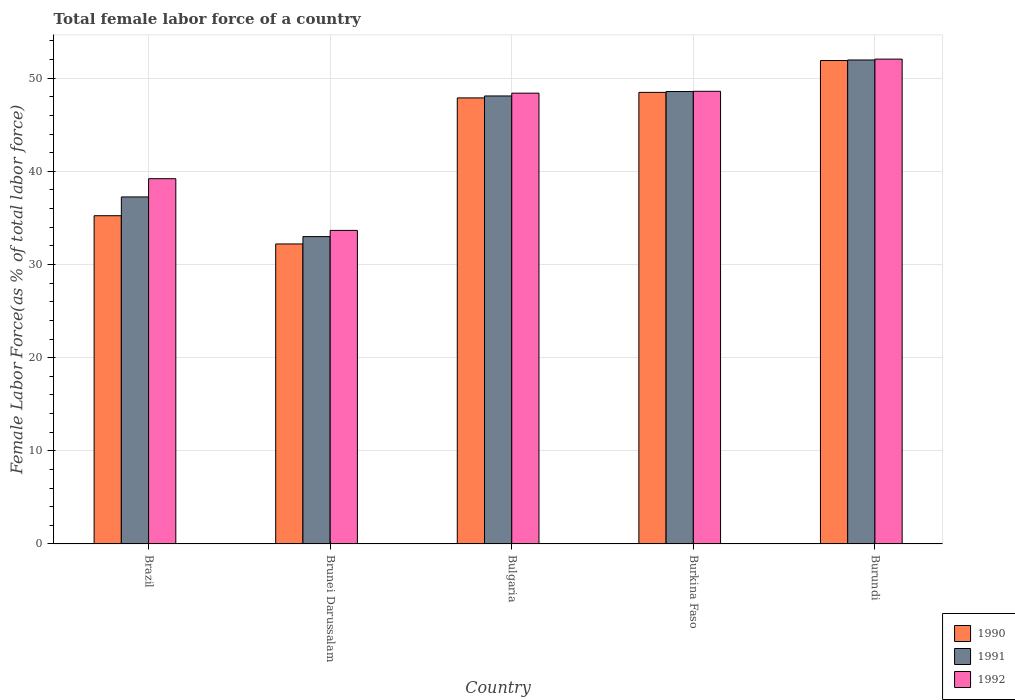How many different coloured bars are there?
Provide a short and direct response. 3. How many groups of bars are there?
Give a very brief answer. 5. What is the label of the 1st group of bars from the left?
Give a very brief answer. Brazil. In how many cases, is the number of bars for a given country not equal to the number of legend labels?
Your response must be concise. 0. What is the percentage of female labor force in 1990 in Brunei Darussalam?
Provide a short and direct response. 32.2. Across all countries, what is the maximum percentage of female labor force in 1990?
Provide a succinct answer. 51.89. Across all countries, what is the minimum percentage of female labor force in 1990?
Your answer should be very brief. 32.2. In which country was the percentage of female labor force in 1991 maximum?
Your answer should be very brief. Burundi. In which country was the percentage of female labor force in 1991 minimum?
Offer a terse response. Brunei Darussalam. What is the total percentage of female labor force in 1992 in the graph?
Provide a short and direct response. 221.91. What is the difference between the percentage of female labor force in 1990 in Brunei Darussalam and that in Bulgaria?
Your answer should be very brief. -15.68. What is the difference between the percentage of female labor force in 1992 in Brunei Darussalam and the percentage of female labor force in 1990 in Burkina Faso?
Give a very brief answer. -14.82. What is the average percentage of female labor force in 1991 per country?
Make the answer very short. 43.77. What is the difference between the percentage of female labor force of/in 1992 and percentage of female labor force of/in 1990 in Bulgaria?
Offer a very short reply. 0.51. What is the ratio of the percentage of female labor force in 1991 in Brunei Darussalam to that in Bulgaria?
Ensure brevity in your answer.  0.69. Is the percentage of female labor force in 1992 in Brunei Darussalam less than that in Burkina Faso?
Offer a very short reply. Yes. Is the difference between the percentage of female labor force in 1992 in Brazil and Bulgaria greater than the difference between the percentage of female labor force in 1990 in Brazil and Bulgaria?
Your response must be concise. Yes. What is the difference between the highest and the second highest percentage of female labor force in 1991?
Your response must be concise. 0.48. What is the difference between the highest and the lowest percentage of female labor force in 1990?
Give a very brief answer. 19.69. In how many countries, is the percentage of female labor force in 1991 greater than the average percentage of female labor force in 1991 taken over all countries?
Your answer should be compact. 3. What does the 3rd bar from the right in Brazil represents?
Offer a terse response. 1990. Is it the case that in every country, the sum of the percentage of female labor force in 1990 and percentage of female labor force in 1992 is greater than the percentage of female labor force in 1991?
Offer a terse response. Yes. How many bars are there?
Provide a short and direct response. 15. Are all the bars in the graph horizontal?
Ensure brevity in your answer.  No. Does the graph contain grids?
Ensure brevity in your answer.  Yes. Where does the legend appear in the graph?
Offer a very short reply. Bottom right. How are the legend labels stacked?
Offer a very short reply. Vertical. What is the title of the graph?
Your response must be concise. Total female labor force of a country. Does "1980" appear as one of the legend labels in the graph?
Make the answer very short. No. What is the label or title of the X-axis?
Keep it short and to the point. Country. What is the label or title of the Y-axis?
Keep it short and to the point. Female Labor Force(as % of total labor force). What is the Female Labor Force(as % of total labor force) in 1990 in Brazil?
Keep it short and to the point. 35.24. What is the Female Labor Force(as % of total labor force) in 1991 in Brazil?
Ensure brevity in your answer.  37.25. What is the Female Labor Force(as % of total labor force) of 1992 in Brazil?
Your response must be concise. 39.21. What is the Female Labor Force(as % of total labor force) in 1990 in Brunei Darussalam?
Your answer should be very brief. 32.2. What is the Female Labor Force(as % of total labor force) in 1991 in Brunei Darussalam?
Your response must be concise. 33. What is the Female Labor Force(as % of total labor force) in 1992 in Brunei Darussalam?
Your answer should be very brief. 33.66. What is the Female Labor Force(as % of total labor force) of 1990 in Bulgaria?
Give a very brief answer. 47.88. What is the Female Labor Force(as % of total labor force) of 1991 in Bulgaria?
Your response must be concise. 48.09. What is the Female Labor Force(as % of total labor force) of 1992 in Bulgaria?
Give a very brief answer. 48.39. What is the Female Labor Force(as % of total labor force) in 1990 in Burkina Faso?
Your answer should be very brief. 48.48. What is the Female Labor Force(as % of total labor force) of 1991 in Burkina Faso?
Make the answer very short. 48.57. What is the Female Labor Force(as % of total labor force) of 1992 in Burkina Faso?
Offer a very short reply. 48.59. What is the Female Labor Force(as % of total labor force) in 1990 in Burundi?
Offer a very short reply. 51.89. What is the Female Labor Force(as % of total labor force) of 1991 in Burundi?
Your response must be concise. 51.96. What is the Female Labor Force(as % of total labor force) of 1992 in Burundi?
Provide a short and direct response. 52.05. Across all countries, what is the maximum Female Labor Force(as % of total labor force) of 1990?
Give a very brief answer. 51.89. Across all countries, what is the maximum Female Labor Force(as % of total labor force) of 1991?
Make the answer very short. 51.96. Across all countries, what is the maximum Female Labor Force(as % of total labor force) of 1992?
Provide a succinct answer. 52.05. Across all countries, what is the minimum Female Labor Force(as % of total labor force) of 1990?
Your response must be concise. 32.2. Across all countries, what is the minimum Female Labor Force(as % of total labor force) in 1991?
Your answer should be compact. 33. Across all countries, what is the minimum Female Labor Force(as % of total labor force) in 1992?
Your answer should be compact. 33.66. What is the total Female Labor Force(as % of total labor force) of 1990 in the graph?
Provide a short and direct response. 215.7. What is the total Female Labor Force(as % of total labor force) of 1991 in the graph?
Offer a terse response. 218.86. What is the total Female Labor Force(as % of total labor force) in 1992 in the graph?
Give a very brief answer. 221.91. What is the difference between the Female Labor Force(as % of total labor force) in 1990 in Brazil and that in Brunei Darussalam?
Keep it short and to the point. 3.03. What is the difference between the Female Labor Force(as % of total labor force) of 1991 in Brazil and that in Brunei Darussalam?
Your response must be concise. 4.26. What is the difference between the Female Labor Force(as % of total labor force) in 1992 in Brazil and that in Brunei Darussalam?
Offer a very short reply. 5.55. What is the difference between the Female Labor Force(as % of total labor force) of 1990 in Brazil and that in Bulgaria?
Keep it short and to the point. -12.65. What is the difference between the Female Labor Force(as % of total labor force) of 1991 in Brazil and that in Bulgaria?
Provide a succinct answer. -10.84. What is the difference between the Female Labor Force(as % of total labor force) of 1992 in Brazil and that in Bulgaria?
Give a very brief answer. -9.18. What is the difference between the Female Labor Force(as % of total labor force) of 1990 in Brazil and that in Burkina Faso?
Your answer should be very brief. -13.24. What is the difference between the Female Labor Force(as % of total labor force) in 1991 in Brazil and that in Burkina Faso?
Your answer should be very brief. -11.31. What is the difference between the Female Labor Force(as % of total labor force) in 1992 in Brazil and that in Burkina Faso?
Your response must be concise. -9.38. What is the difference between the Female Labor Force(as % of total labor force) in 1990 in Brazil and that in Burundi?
Your answer should be compact. -16.66. What is the difference between the Female Labor Force(as % of total labor force) in 1991 in Brazil and that in Burundi?
Your response must be concise. -14.7. What is the difference between the Female Labor Force(as % of total labor force) of 1992 in Brazil and that in Burundi?
Make the answer very short. -12.84. What is the difference between the Female Labor Force(as % of total labor force) in 1990 in Brunei Darussalam and that in Bulgaria?
Offer a terse response. -15.68. What is the difference between the Female Labor Force(as % of total labor force) in 1991 in Brunei Darussalam and that in Bulgaria?
Offer a terse response. -15.1. What is the difference between the Female Labor Force(as % of total labor force) in 1992 in Brunei Darussalam and that in Bulgaria?
Your answer should be compact. -14.73. What is the difference between the Female Labor Force(as % of total labor force) of 1990 in Brunei Darussalam and that in Burkina Faso?
Provide a short and direct response. -16.27. What is the difference between the Female Labor Force(as % of total labor force) in 1991 in Brunei Darussalam and that in Burkina Faso?
Provide a succinct answer. -15.57. What is the difference between the Female Labor Force(as % of total labor force) in 1992 in Brunei Darussalam and that in Burkina Faso?
Ensure brevity in your answer.  -14.93. What is the difference between the Female Labor Force(as % of total labor force) of 1990 in Brunei Darussalam and that in Burundi?
Provide a short and direct response. -19.69. What is the difference between the Female Labor Force(as % of total labor force) of 1991 in Brunei Darussalam and that in Burundi?
Provide a succinct answer. -18.96. What is the difference between the Female Labor Force(as % of total labor force) in 1992 in Brunei Darussalam and that in Burundi?
Offer a terse response. -18.39. What is the difference between the Female Labor Force(as % of total labor force) in 1990 in Bulgaria and that in Burkina Faso?
Give a very brief answer. -0.59. What is the difference between the Female Labor Force(as % of total labor force) in 1991 in Bulgaria and that in Burkina Faso?
Provide a succinct answer. -0.48. What is the difference between the Female Labor Force(as % of total labor force) in 1992 in Bulgaria and that in Burkina Faso?
Your answer should be compact. -0.2. What is the difference between the Female Labor Force(as % of total labor force) of 1990 in Bulgaria and that in Burundi?
Keep it short and to the point. -4.01. What is the difference between the Female Labor Force(as % of total labor force) of 1991 in Bulgaria and that in Burundi?
Make the answer very short. -3.86. What is the difference between the Female Labor Force(as % of total labor force) in 1992 in Bulgaria and that in Burundi?
Provide a succinct answer. -3.65. What is the difference between the Female Labor Force(as % of total labor force) of 1990 in Burkina Faso and that in Burundi?
Provide a succinct answer. -3.42. What is the difference between the Female Labor Force(as % of total labor force) in 1991 in Burkina Faso and that in Burundi?
Make the answer very short. -3.39. What is the difference between the Female Labor Force(as % of total labor force) in 1992 in Burkina Faso and that in Burundi?
Keep it short and to the point. -3.45. What is the difference between the Female Labor Force(as % of total labor force) in 1990 in Brazil and the Female Labor Force(as % of total labor force) in 1991 in Brunei Darussalam?
Make the answer very short. 2.24. What is the difference between the Female Labor Force(as % of total labor force) in 1990 in Brazil and the Female Labor Force(as % of total labor force) in 1992 in Brunei Darussalam?
Your answer should be very brief. 1.58. What is the difference between the Female Labor Force(as % of total labor force) of 1991 in Brazil and the Female Labor Force(as % of total labor force) of 1992 in Brunei Darussalam?
Your response must be concise. 3.59. What is the difference between the Female Labor Force(as % of total labor force) of 1990 in Brazil and the Female Labor Force(as % of total labor force) of 1991 in Bulgaria?
Provide a short and direct response. -12.86. What is the difference between the Female Labor Force(as % of total labor force) in 1990 in Brazil and the Female Labor Force(as % of total labor force) in 1992 in Bulgaria?
Provide a short and direct response. -13.16. What is the difference between the Female Labor Force(as % of total labor force) in 1991 in Brazil and the Female Labor Force(as % of total labor force) in 1992 in Bulgaria?
Provide a succinct answer. -11.14. What is the difference between the Female Labor Force(as % of total labor force) of 1990 in Brazil and the Female Labor Force(as % of total labor force) of 1991 in Burkina Faso?
Make the answer very short. -13.33. What is the difference between the Female Labor Force(as % of total labor force) of 1990 in Brazil and the Female Labor Force(as % of total labor force) of 1992 in Burkina Faso?
Provide a succinct answer. -13.36. What is the difference between the Female Labor Force(as % of total labor force) in 1991 in Brazil and the Female Labor Force(as % of total labor force) in 1992 in Burkina Faso?
Provide a succinct answer. -11.34. What is the difference between the Female Labor Force(as % of total labor force) in 1990 in Brazil and the Female Labor Force(as % of total labor force) in 1991 in Burundi?
Your answer should be compact. -16.72. What is the difference between the Female Labor Force(as % of total labor force) in 1990 in Brazil and the Female Labor Force(as % of total labor force) in 1992 in Burundi?
Give a very brief answer. -16.81. What is the difference between the Female Labor Force(as % of total labor force) of 1991 in Brazil and the Female Labor Force(as % of total labor force) of 1992 in Burundi?
Offer a terse response. -14.79. What is the difference between the Female Labor Force(as % of total labor force) in 1990 in Brunei Darussalam and the Female Labor Force(as % of total labor force) in 1991 in Bulgaria?
Your answer should be very brief. -15.89. What is the difference between the Female Labor Force(as % of total labor force) in 1990 in Brunei Darussalam and the Female Labor Force(as % of total labor force) in 1992 in Bulgaria?
Keep it short and to the point. -16.19. What is the difference between the Female Labor Force(as % of total labor force) of 1991 in Brunei Darussalam and the Female Labor Force(as % of total labor force) of 1992 in Bulgaria?
Provide a succinct answer. -15.4. What is the difference between the Female Labor Force(as % of total labor force) in 1990 in Brunei Darussalam and the Female Labor Force(as % of total labor force) in 1991 in Burkina Faso?
Provide a succinct answer. -16.36. What is the difference between the Female Labor Force(as % of total labor force) in 1990 in Brunei Darussalam and the Female Labor Force(as % of total labor force) in 1992 in Burkina Faso?
Your answer should be very brief. -16.39. What is the difference between the Female Labor Force(as % of total labor force) of 1991 in Brunei Darussalam and the Female Labor Force(as % of total labor force) of 1992 in Burkina Faso?
Ensure brevity in your answer.  -15.6. What is the difference between the Female Labor Force(as % of total labor force) of 1990 in Brunei Darussalam and the Female Labor Force(as % of total labor force) of 1991 in Burundi?
Offer a terse response. -19.75. What is the difference between the Female Labor Force(as % of total labor force) of 1990 in Brunei Darussalam and the Female Labor Force(as % of total labor force) of 1992 in Burundi?
Your answer should be compact. -19.84. What is the difference between the Female Labor Force(as % of total labor force) of 1991 in Brunei Darussalam and the Female Labor Force(as % of total labor force) of 1992 in Burundi?
Your answer should be very brief. -19.05. What is the difference between the Female Labor Force(as % of total labor force) of 1990 in Bulgaria and the Female Labor Force(as % of total labor force) of 1991 in Burkina Faso?
Provide a short and direct response. -0.68. What is the difference between the Female Labor Force(as % of total labor force) of 1990 in Bulgaria and the Female Labor Force(as % of total labor force) of 1992 in Burkina Faso?
Your response must be concise. -0.71. What is the difference between the Female Labor Force(as % of total labor force) in 1991 in Bulgaria and the Female Labor Force(as % of total labor force) in 1992 in Burkina Faso?
Keep it short and to the point. -0.5. What is the difference between the Female Labor Force(as % of total labor force) of 1990 in Bulgaria and the Female Labor Force(as % of total labor force) of 1991 in Burundi?
Your answer should be compact. -4.07. What is the difference between the Female Labor Force(as % of total labor force) of 1990 in Bulgaria and the Female Labor Force(as % of total labor force) of 1992 in Burundi?
Keep it short and to the point. -4.16. What is the difference between the Female Labor Force(as % of total labor force) of 1991 in Bulgaria and the Female Labor Force(as % of total labor force) of 1992 in Burundi?
Offer a terse response. -3.95. What is the difference between the Female Labor Force(as % of total labor force) of 1990 in Burkina Faso and the Female Labor Force(as % of total labor force) of 1991 in Burundi?
Your answer should be compact. -3.48. What is the difference between the Female Labor Force(as % of total labor force) of 1990 in Burkina Faso and the Female Labor Force(as % of total labor force) of 1992 in Burundi?
Keep it short and to the point. -3.57. What is the difference between the Female Labor Force(as % of total labor force) in 1991 in Burkina Faso and the Female Labor Force(as % of total labor force) in 1992 in Burundi?
Provide a short and direct response. -3.48. What is the average Female Labor Force(as % of total labor force) in 1990 per country?
Keep it short and to the point. 43.14. What is the average Female Labor Force(as % of total labor force) of 1991 per country?
Provide a succinct answer. 43.77. What is the average Female Labor Force(as % of total labor force) in 1992 per country?
Your answer should be compact. 44.38. What is the difference between the Female Labor Force(as % of total labor force) in 1990 and Female Labor Force(as % of total labor force) in 1991 in Brazil?
Your response must be concise. -2.02. What is the difference between the Female Labor Force(as % of total labor force) in 1990 and Female Labor Force(as % of total labor force) in 1992 in Brazil?
Your response must be concise. -3.97. What is the difference between the Female Labor Force(as % of total labor force) of 1991 and Female Labor Force(as % of total labor force) of 1992 in Brazil?
Ensure brevity in your answer.  -1.96. What is the difference between the Female Labor Force(as % of total labor force) in 1990 and Female Labor Force(as % of total labor force) in 1991 in Brunei Darussalam?
Offer a terse response. -0.79. What is the difference between the Female Labor Force(as % of total labor force) of 1990 and Female Labor Force(as % of total labor force) of 1992 in Brunei Darussalam?
Provide a short and direct response. -1.46. What is the difference between the Female Labor Force(as % of total labor force) in 1991 and Female Labor Force(as % of total labor force) in 1992 in Brunei Darussalam?
Provide a succinct answer. -0.66. What is the difference between the Female Labor Force(as % of total labor force) of 1990 and Female Labor Force(as % of total labor force) of 1991 in Bulgaria?
Your answer should be compact. -0.21. What is the difference between the Female Labor Force(as % of total labor force) in 1990 and Female Labor Force(as % of total labor force) in 1992 in Bulgaria?
Keep it short and to the point. -0.51. What is the difference between the Female Labor Force(as % of total labor force) in 1991 and Female Labor Force(as % of total labor force) in 1992 in Bulgaria?
Make the answer very short. -0.3. What is the difference between the Female Labor Force(as % of total labor force) in 1990 and Female Labor Force(as % of total labor force) in 1991 in Burkina Faso?
Provide a succinct answer. -0.09. What is the difference between the Female Labor Force(as % of total labor force) in 1990 and Female Labor Force(as % of total labor force) in 1992 in Burkina Faso?
Offer a very short reply. -0.12. What is the difference between the Female Labor Force(as % of total labor force) of 1991 and Female Labor Force(as % of total labor force) of 1992 in Burkina Faso?
Provide a succinct answer. -0.03. What is the difference between the Female Labor Force(as % of total labor force) of 1990 and Female Labor Force(as % of total labor force) of 1991 in Burundi?
Your answer should be compact. -0.06. What is the difference between the Female Labor Force(as % of total labor force) of 1990 and Female Labor Force(as % of total labor force) of 1992 in Burundi?
Your answer should be compact. -0.15. What is the difference between the Female Labor Force(as % of total labor force) in 1991 and Female Labor Force(as % of total labor force) in 1992 in Burundi?
Give a very brief answer. -0.09. What is the ratio of the Female Labor Force(as % of total labor force) in 1990 in Brazil to that in Brunei Darussalam?
Keep it short and to the point. 1.09. What is the ratio of the Female Labor Force(as % of total labor force) in 1991 in Brazil to that in Brunei Darussalam?
Make the answer very short. 1.13. What is the ratio of the Female Labor Force(as % of total labor force) of 1992 in Brazil to that in Brunei Darussalam?
Offer a very short reply. 1.16. What is the ratio of the Female Labor Force(as % of total labor force) in 1990 in Brazil to that in Bulgaria?
Your response must be concise. 0.74. What is the ratio of the Female Labor Force(as % of total labor force) of 1991 in Brazil to that in Bulgaria?
Your response must be concise. 0.77. What is the ratio of the Female Labor Force(as % of total labor force) of 1992 in Brazil to that in Bulgaria?
Offer a terse response. 0.81. What is the ratio of the Female Labor Force(as % of total labor force) in 1990 in Brazil to that in Burkina Faso?
Keep it short and to the point. 0.73. What is the ratio of the Female Labor Force(as % of total labor force) of 1991 in Brazil to that in Burkina Faso?
Your answer should be very brief. 0.77. What is the ratio of the Female Labor Force(as % of total labor force) of 1992 in Brazil to that in Burkina Faso?
Provide a short and direct response. 0.81. What is the ratio of the Female Labor Force(as % of total labor force) in 1990 in Brazil to that in Burundi?
Your response must be concise. 0.68. What is the ratio of the Female Labor Force(as % of total labor force) of 1991 in Brazil to that in Burundi?
Keep it short and to the point. 0.72. What is the ratio of the Female Labor Force(as % of total labor force) of 1992 in Brazil to that in Burundi?
Offer a very short reply. 0.75. What is the ratio of the Female Labor Force(as % of total labor force) in 1990 in Brunei Darussalam to that in Bulgaria?
Offer a very short reply. 0.67. What is the ratio of the Female Labor Force(as % of total labor force) of 1991 in Brunei Darussalam to that in Bulgaria?
Your response must be concise. 0.69. What is the ratio of the Female Labor Force(as % of total labor force) of 1992 in Brunei Darussalam to that in Bulgaria?
Offer a very short reply. 0.7. What is the ratio of the Female Labor Force(as % of total labor force) of 1990 in Brunei Darussalam to that in Burkina Faso?
Ensure brevity in your answer.  0.66. What is the ratio of the Female Labor Force(as % of total labor force) of 1991 in Brunei Darussalam to that in Burkina Faso?
Your answer should be very brief. 0.68. What is the ratio of the Female Labor Force(as % of total labor force) of 1992 in Brunei Darussalam to that in Burkina Faso?
Provide a short and direct response. 0.69. What is the ratio of the Female Labor Force(as % of total labor force) of 1990 in Brunei Darussalam to that in Burundi?
Offer a terse response. 0.62. What is the ratio of the Female Labor Force(as % of total labor force) of 1991 in Brunei Darussalam to that in Burundi?
Ensure brevity in your answer.  0.64. What is the ratio of the Female Labor Force(as % of total labor force) of 1992 in Brunei Darussalam to that in Burundi?
Provide a short and direct response. 0.65. What is the ratio of the Female Labor Force(as % of total labor force) of 1990 in Bulgaria to that in Burkina Faso?
Your answer should be compact. 0.99. What is the ratio of the Female Labor Force(as % of total labor force) in 1991 in Bulgaria to that in Burkina Faso?
Your answer should be very brief. 0.99. What is the ratio of the Female Labor Force(as % of total labor force) of 1990 in Bulgaria to that in Burundi?
Offer a terse response. 0.92. What is the ratio of the Female Labor Force(as % of total labor force) in 1991 in Bulgaria to that in Burundi?
Your answer should be very brief. 0.93. What is the ratio of the Female Labor Force(as % of total labor force) of 1992 in Bulgaria to that in Burundi?
Provide a short and direct response. 0.93. What is the ratio of the Female Labor Force(as % of total labor force) in 1990 in Burkina Faso to that in Burundi?
Make the answer very short. 0.93. What is the ratio of the Female Labor Force(as % of total labor force) of 1991 in Burkina Faso to that in Burundi?
Ensure brevity in your answer.  0.93. What is the ratio of the Female Labor Force(as % of total labor force) in 1992 in Burkina Faso to that in Burundi?
Offer a very short reply. 0.93. What is the difference between the highest and the second highest Female Labor Force(as % of total labor force) in 1990?
Make the answer very short. 3.42. What is the difference between the highest and the second highest Female Labor Force(as % of total labor force) in 1991?
Keep it short and to the point. 3.39. What is the difference between the highest and the second highest Female Labor Force(as % of total labor force) in 1992?
Offer a very short reply. 3.45. What is the difference between the highest and the lowest Female Labor Force(as % of total labor force) of 1990?
Provide a short and direct response. 19.69. What is the difference between the highest and the lowest Female Labor Force(as % of total labor force) of 1991?
Your answer should be compact. 18.96. What is the difference between the highest and the lowest Female Labor Force(as % of total labor force) in 1992?
Ensure brevity in your answer.  18.39. 